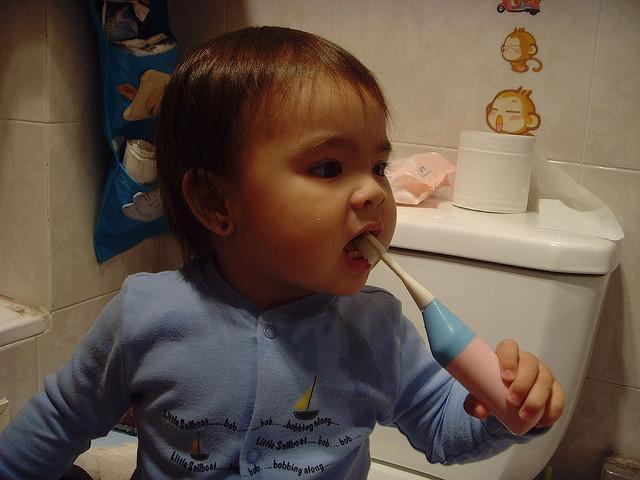How many stripes are on the towel?
Give a very brief answer. 0. How many cars on the road?
Give a very brief answer. 0. 